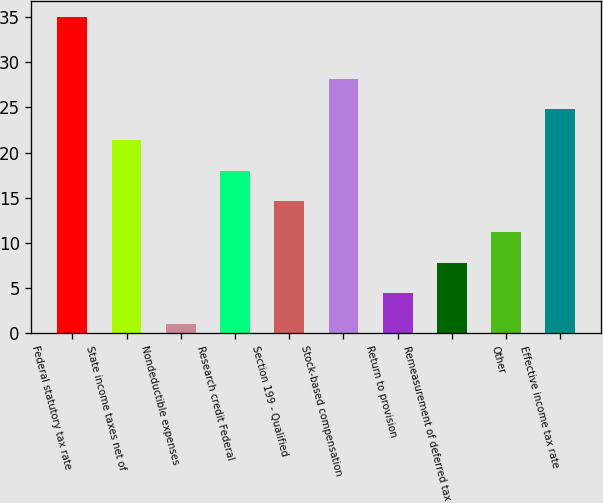<chart> <loc_0><loc_0><loc_500><loc_500><bar_chart><fcel>Federal statutory tax rate<fcel>State income taxes net of<fcel>Nondeductible expenses<fcel>Research credit Federal<fcel>Section 199 - Qualified<fcel>Stock-based compensation<fcel>Return to provision<fcel>Remeasurement of deferred tax<fcel>Other<fcel>Effective income tax rate<nl><fcel>35<fcel>21.4<fcel>1<fcel>18<fcel>14.6<fcel>28.2<fcel>4.4<fcel>7.8<fcel>11.2<fcel>24.8<nl></chart> 